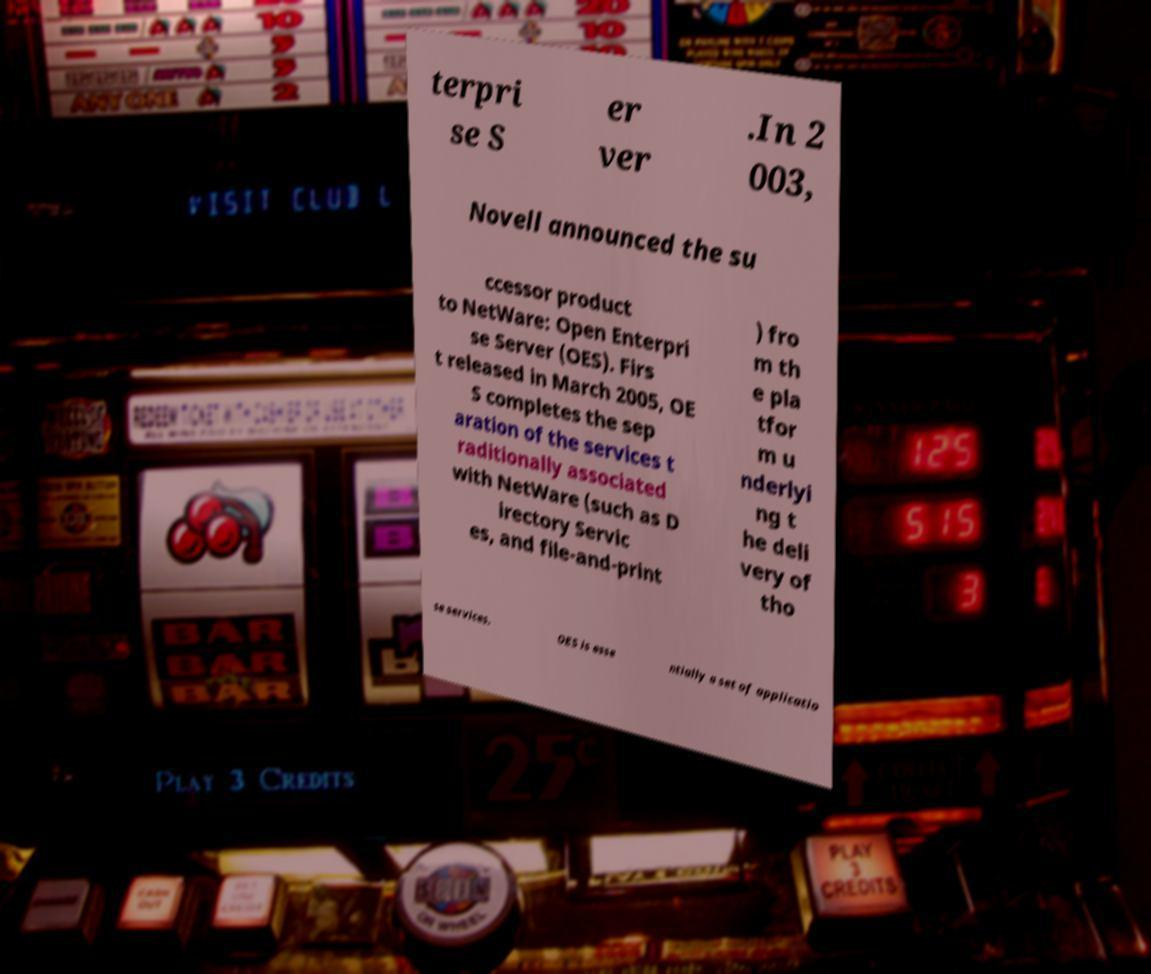Please read and relay the text visible in this image. What does it say? terpri se S er ver .In 2 003, Novell announced the su ccessor product to NetWare: Open Enterpri se Server (OES). Firs t released in March 2005, OE S completes the sep aration of the services t raditionally associated with NetWare (such as D irectory Servic es, and file-and-print ) fro m th e pla tfor m u nderlyi ng t he deli very of tho se services. OES is esse ntially a set of applicatio 